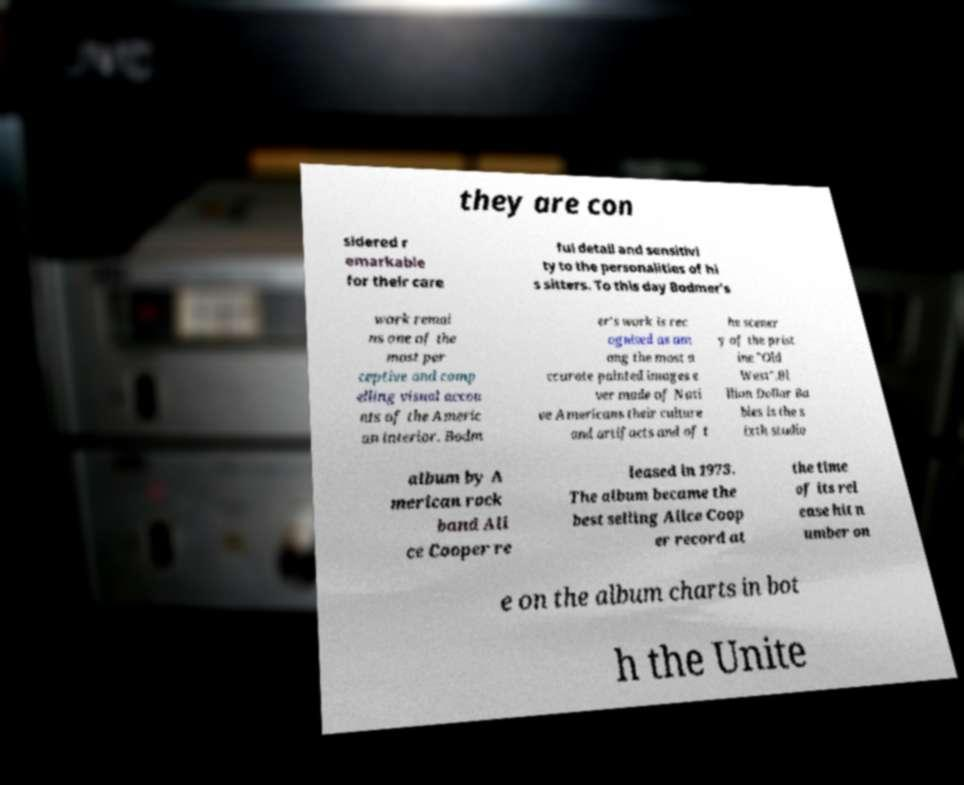Could you extract and type out the text from this image? they are con sidered r emarkable for their care ful detail and sensitivi ty to the personalities of hi s sitters. To this day Bodmer's work remai ns one of the most per ceptive and comp elling visual accou nts of the Americ an interior. Bodm er's work is rec ognised as am ong the most a ccurate painted images e ver made of Nati ve Americans their culture and artifacts and of t he scener y of the prist ine "Old West".Bi llion Dollar Ba bies is the s ixth studio album by A merican rock band Ali ce Cooper re leased in 1973. The album became the best selling Alice Coop er record at the time of its rel ease hit n umber on e on the album charts in bot h the Unite 